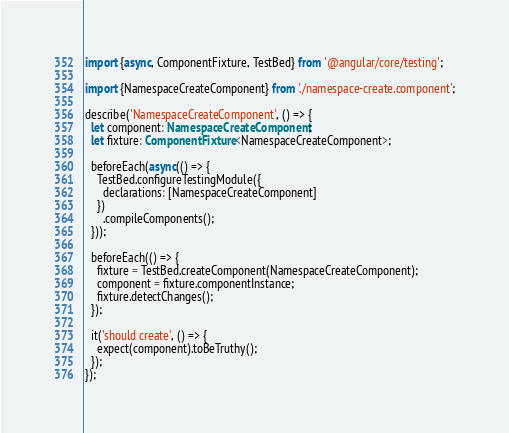Convert code to text. <code><loc_0><loc_0><loc_500><loc_500><_TypeScript_>import {async, ComponentFixture, TestBed} from '@angular/core/testing';

import {NamespaceCreateComponent} from './namespace-create.component';

describe('NamespaceCreateComponent', () => {
  let component: NamespaceCreateComponent;
  let fixture: ComponentFixture<NamespaceCreateComponent>;

  beforeEach(async(() => {
    TestBed.configureTestingModule({
      declarations: [NamespaceCreateComponent]
    })
      .compileComponents();
  }));

  beforeEach(() => {
    fixture = TestBed.createComponent(NamespaceCreateComponent);
    component = fixture.componentInstance;
    fixture.detectChanges();
  });

  it('should create', () => {
    expect(component).toBeTruthy();
  });
});
</code> 